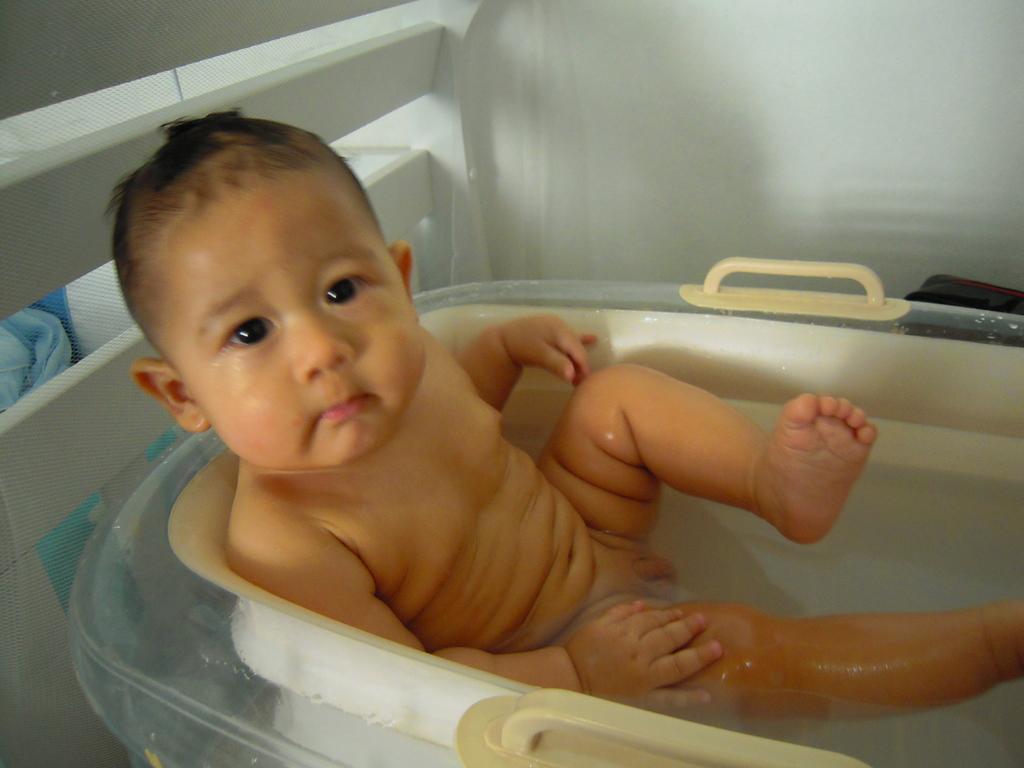How would you summarize this image in a sentence or two? In this image we can see a baby in the bathtub. In the background of the image there is a wall, mesh and other objects. 